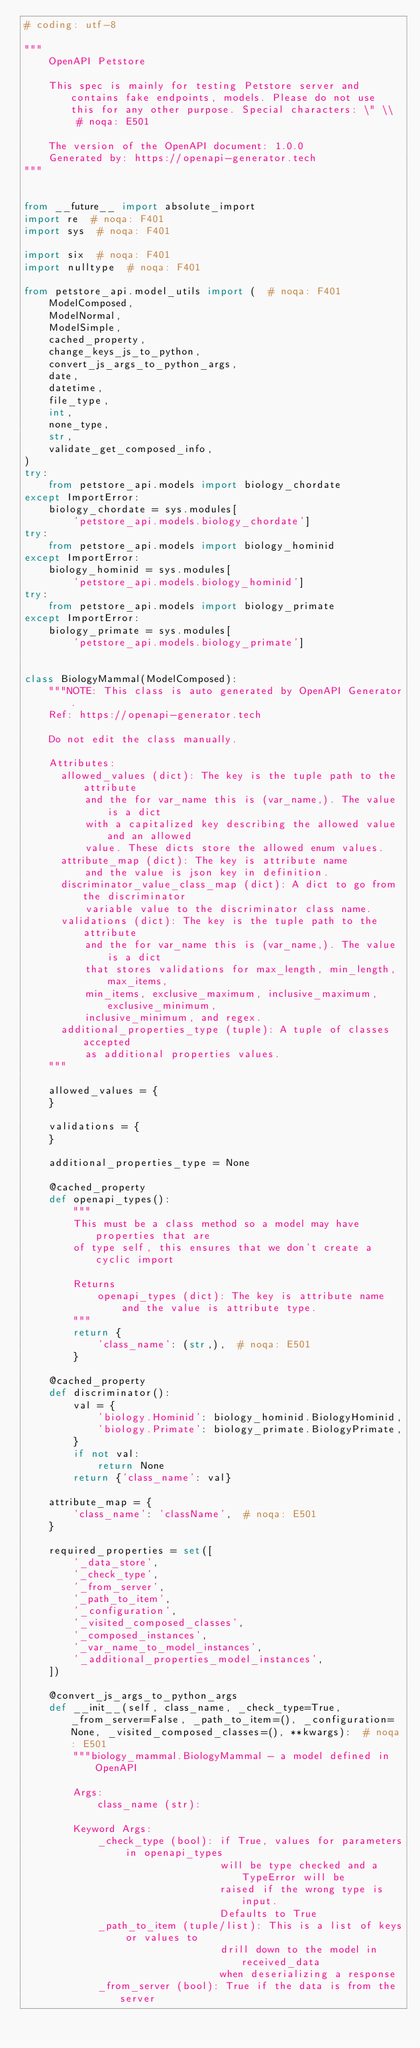Convert code to text. <code><loc_0><loc_0><loc_500><loc_500><_Python_># coding: utf-8

"""
    OpenAPI Petstore

    This spec is mainly for testing Petstore server and contains fake endpoints, models. Please do not use this for any other purpose. Special characters: \" \\  # noqa: E501

    The version of the OpenAPI document: 1.0.0
    Generated by: https://openapi-generator.tech
"""


from __future__ import absolute_import
import re  # noqa: F401
import sys  # noqa: F401

import six  # noqa: F401
import nulltype  # noqa: F401

from petstore_api.model_utils import (  # noqa: F401
    ModelComposed,
    ModelNormal,
    ModelSimple,
    cached_property,
    change_keys_js_to_python,
    convert_js_args_to_python_args,
    date,
    datetime,
    file_type,
    int,
    none_type,
    str,
    validate_get_composed_info,
)
try:
    from petstore_api.models import biology_chordate
except ImportError:
    biology_chordate = sys.modules[
        'petstore_api.models.biology_chordate']
try:
    from petstore_api.models import biology_hominid
except ImportError:
    biology_hominid = sys.modules[
        'petstore_api.models.biology_hominid']
try:
    from petstore_api.models import biology_primate
except ImportError:
    biology_primate = sys.modules[
        'petstore_api.models.biology_primate']


class BiologyMammal(ModelComposed):
    """NOTE: This class is auto generated by OpenAPI Generator.
    Ref: https://openapi-generator.tech

    Do not edit the class manually.

    Attributes:
      allowed_values (dict): The key is the tuple path to the attribute
          and the for var_name this is (var_name,). The value is a dict
          with a capitalized key describing the allowed value and an allowed
          value. These dicts store the allowed enum values.
      attribute_map (dict): The key is attribute name
          and the value is json key in definition.
      discriminator_value_class_map (dict): A dict to go from the discriminator
          variable value to the discriminator class name.
      validations (dict): The key is the tuple path to the attribute
          and the for var_name this is (var_name,). The value is a dict
          that stores validations for max_length, min_length, max_items,
          min_items, exclusive_maximum, inclusive_maximum, exclusive_minimum,
          inclusive_minimum, and regex.
      additional_properties_type (tuple): A tuple of classes accepted
          as additional properties values.
    """

    allowed_values = {
    }

    validations = {
    }

    additional_properties_type = None

    @cached_property
    def openapi_types():
        """
        This must be a class method so a model may have properties that are
        of type self, this ensures that we don't create a cyclic import

        Returns
            openapi_types (dict): The key is attribute name
                and the value is attribute type.
        """
        return {
            'class_name': (str,),  # noqa: E501
        }

    @cached_property
    def discriminator():
        val = {
            'biology.Hominid': biology_hominid.BiologyHominid,
            'biology.Primate': biology_primate.BiologyPrimate,
        }
        if not val:
            return None
        return {'class_name': val}

    attribute_map = {
        'class_name': 'className',  # noqa: E501
    }

    required_properties = set([
        '_data_store',
        '_check_type',
        '_from_server',
        '_path_to_item',
        '_configuration',
        '_visited_composed_classes',
        '_composed_instances',
        '_var_name_to_model_instances',
        '_additional_properties_model_instances',
    ])

    @convert_js_args_to_python_args
    def __init__(self, class_name, _check_type=True, _from_server=False, _path_to_item=(), _configuration=None, _visited_composed_classes=(), **kwargs):  # noqa: E501
        """biology_mammal.BiologyMammal - a model defined in OpenAPI

        Args:
            class_name (str):

        Keyword Args:
            _check_type (bool): if True, values for parameters in openapi_types
                                will be type checked and a TypeError will be
                                raised if the wrong type is input.
                                Defaults to True
            _path_to_item (tuple/list): This is a list of keys or values to
                                drill down to the model in received_data
                                when deserializing a response
            _from_server (bool): True if the data is from the server</code> 